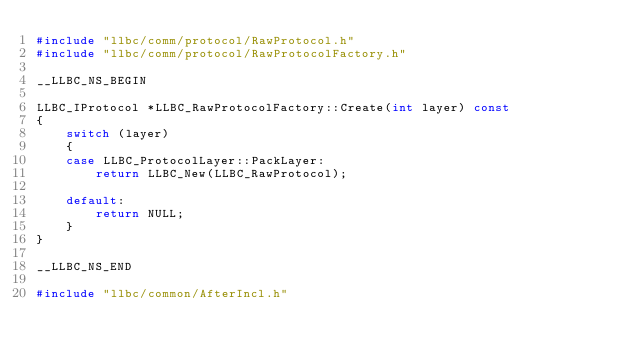<code> <loc_0><loc_0><loc_500><loc_500><_C++_>#include "llbc/comm/protocol/RawProtocol.h"
#include "llbc/comm/protocol/RawProtocolFactory.h"

__LLBC_NS_BEGIN

LLBC_IProtocol *LLBC_RawProtocolFactory::Create(int layer) const
{
    switch (layer)
    {
    case LLBC_ProtocolLayer::PackLayer:
        return LLBC_New(LLBC_RawProtocol);

    default:
        return NULL;
    }
}

__LLBC_NS_END

#include "llbc/common/AfterIncl.h"
</code> 